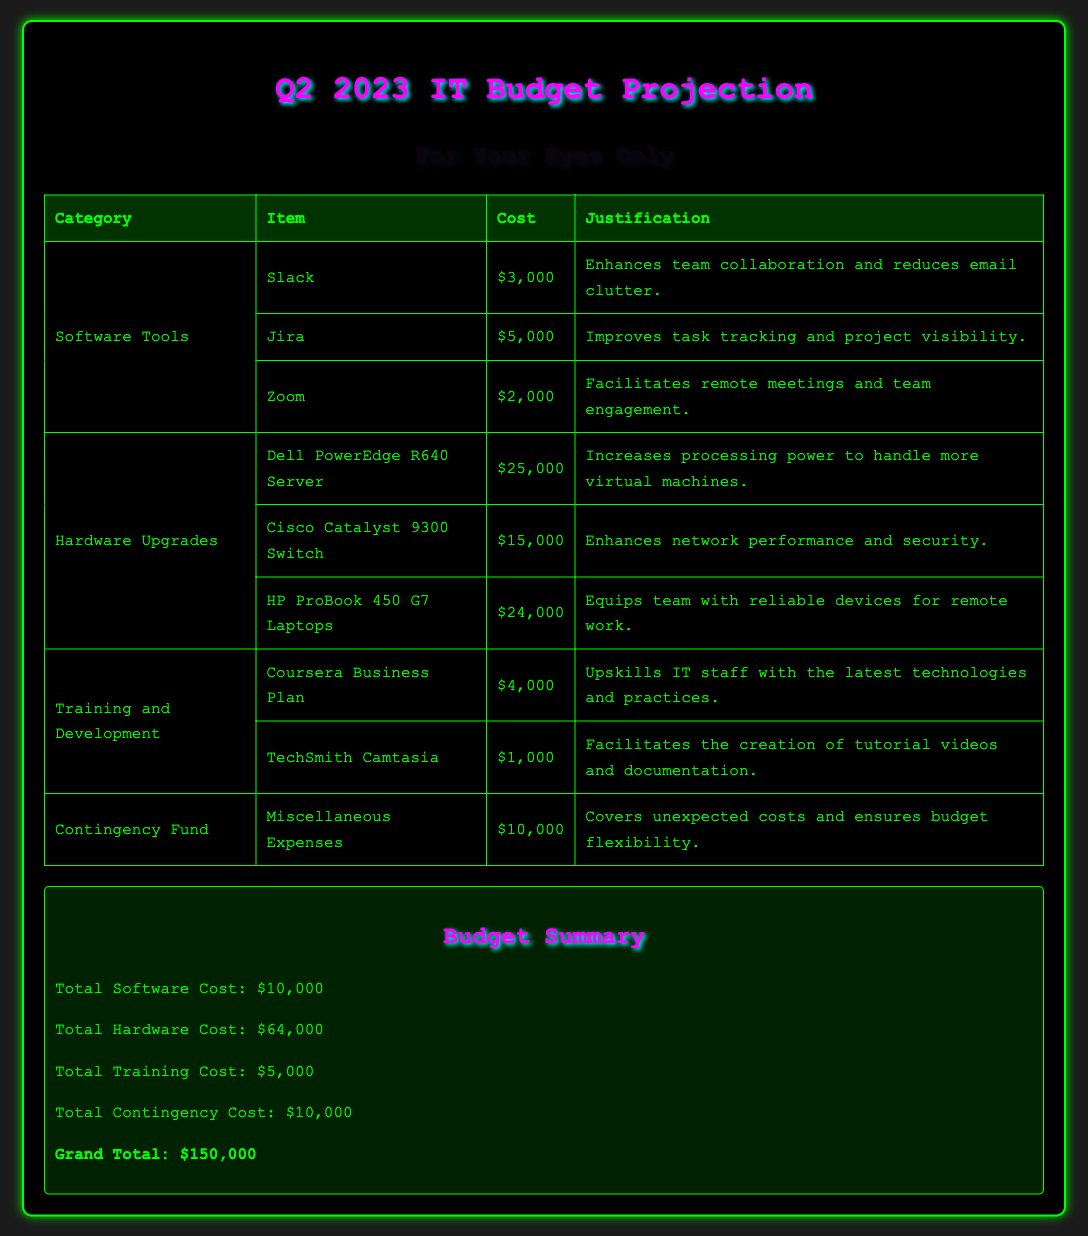What is the total cost for software tools? The total cost for software tools is calculated by summing all the individual software tool costs: $3,000 + $5,000 + $2,000 = $10,000.
Answer: $10,000 What is the cost of the Dell PowerEdge R640 Server? The cost of the Dell PowerEdge R640 Server is given in the hardware upgrades section of the document.
Answer: $25,000 How much is allocated for the contingency fund? The allocation for the contingency fund is explicitly mentioned in the document.
Answer: $10,000 What item costs the most in hardware upgrades? To find out which hardware upgrade costs the most, we compare the costs listed: $25,000, $15,000, and $24,000.
Answer: Dell PowerEdge R640 Server How much is proposed for training and development? The proposed cost for training and development is the sum of its individual costs: $4,000 + $1,000 = $5,000.
Answer: $5,000 What is the grand total budget? The grand total budget is clearly stated after listing all the individual costs.
Answer: $150,000 Which software tool aids in remote meetings? The document specifies Slack, Jira, and Zoom as software tools; Zoom is mentioned specifically for its role in remote meetings.
Answer: Zoom How many hardware items are proposed in the budget? The number of hardware items can be counted in the hardware upgrades section of the document.
Answer: 3 What would be a justification for using Jira? The justification for using Jira is provided in relation to its function and utility in project management.
Answer: Improves task tracking and project visibility 